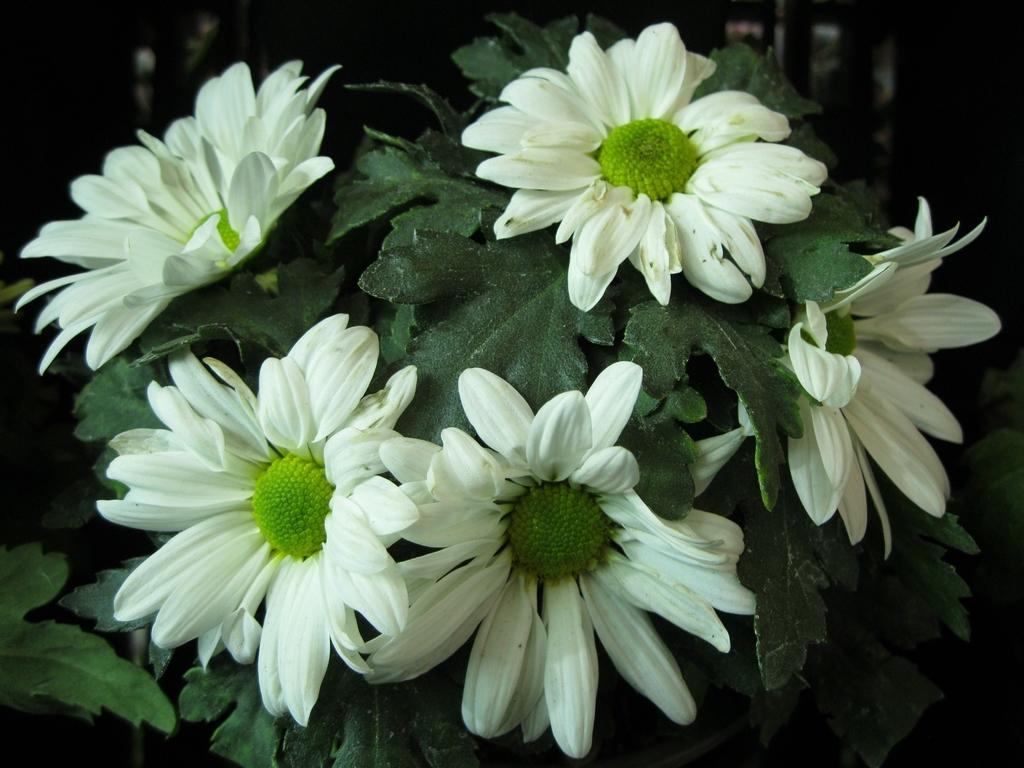What type of plant is in the image? There is a white sunflower plant in the image. What type of map can be seen in the image? There is no map present in the image; it features a white sunflower plant. What is the size of the thumb in the image? There is no thumb present in the image, so it is not possible to determine its size. 